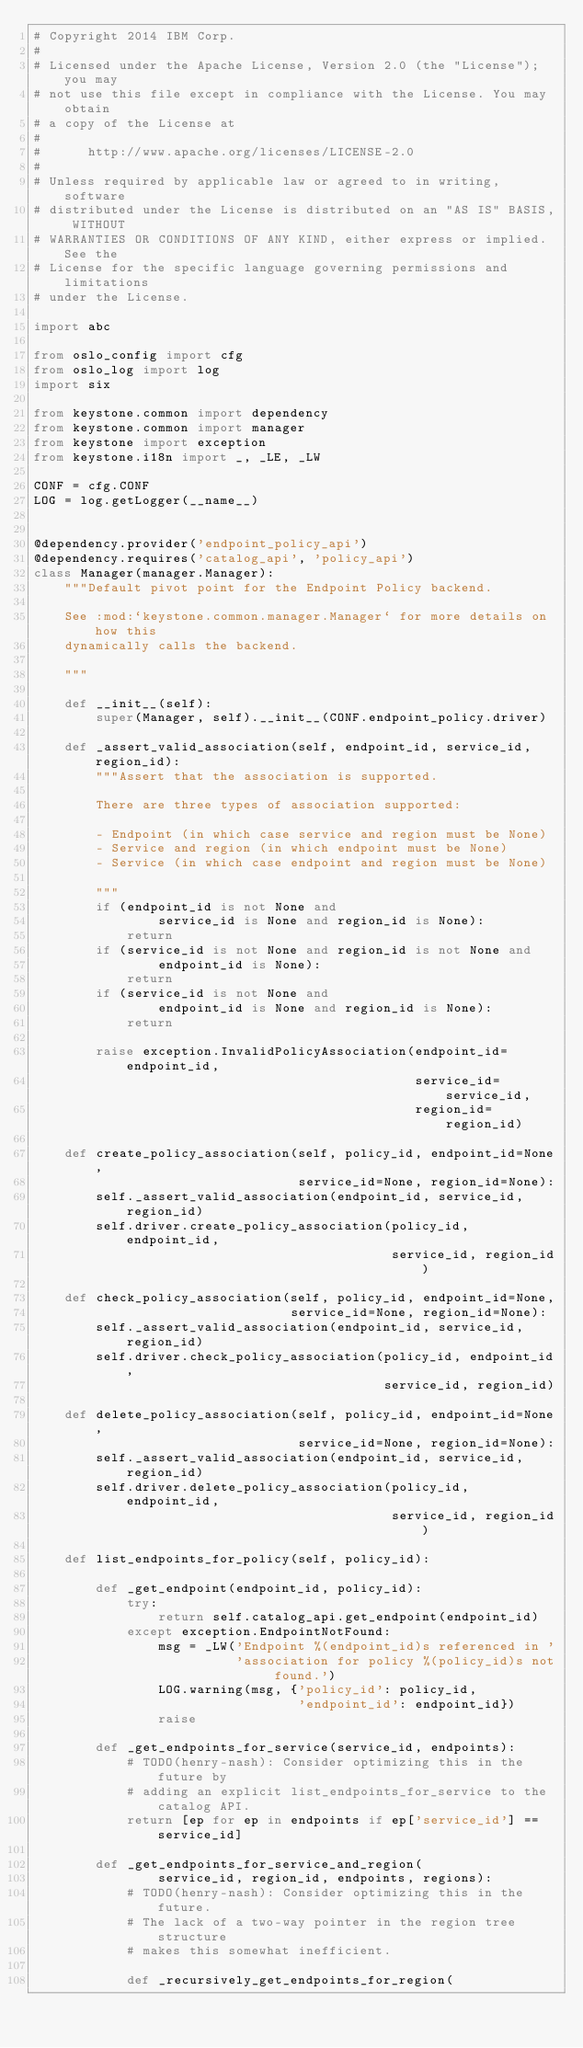<code> <loc_0><loc_0><loc_500><loc_500><_Python_># Copyright 2014 IBM Corp.
#
# Licensed under the Apache License, Version 2.0 (the "License"); you may
# not use this file except in compliance with the License. You may obtain
# a copy of the License at
#
#      http://www.apache.org/licenses/LICENSE-2.0
#
# Unless required by applicable law or agreed to in writing, software
# distributed under the License is distributed on an "AS IS" BASIS, WITHOUT
# WARRANTIES OR CONDITIONS OF ANY KIND, either express or implied. See the
# License for the specific language governing permissions and limitations
# under the License.

import abc

from oslo_config import cfg
from oslo_log import log
import six

from keystone.common import dependency
from keystone.common import manager
from keystone import exception
from keystone.i18n import _, _LE, _LW

CONF = cfg.CONF
LOG = log.getLogger(__name__)


@dependency.provider('endpoint_policy_api')
@dependency.requires('catalog_api', 'policy_api')
class Manager(manager.Manager):
    """Default pivot point for the Endpoint Policy backend.

    See :mod:`keystone.common.manager.Manager` for more details on how this
    dynamically calls the backend.

    """

    def __init__(self):
        super(Manager, self).__init__(CONF.endpoint_policy.driver)

    def _assert_valid_association(self, endpoint_id, service_id, region_id):
        """Assert that the association is supported.

        There are three types of association supported:

        - Endpoint (in which case service and region must be None)
        - Service and region (in which endpoint must be None)
        - Service (in which case endpoint and region must be None)

        """
        if (endpoint_id is not None and
                service_id is None and region_id is None):
            return
        if (service_id is not None and region_id is not None and
                endpoint_id is None):
            return
        if (service_id is not None and
                endpoint_id is None and region_id is None):
            return

        raise exception.InvalidPolicyAssociation(endpoint_id=endpoint_id,
                                                 service_id=service_id,
                                                 region_id=region_id)

    def create_policy_association(self, policy_id, endpoint_id=None,
                                  service_id=None, region_id=None):
        self._assert_valid_association(endpoint_id, service_id, region_id)
        self.driver.create_policy_association(policy_id, endpoint_id,
                                              service_id, region_id)

    def check_policy_association(self, policy_id, endpoint_id=None,
                                 service_id=None, region_id=None):
        self._assert_valid_association(endpoint_id, service_id, region_id)
        self.driver.check_policy_association(policy_id, endpoint_id,
                                             service_id, region_id)

    def delete_policy_association(self, policy_id, endpoint_id=None,
                                  service_id=None, region_id=None):
        self._assert_valid_association(endpoint_id, service_id, region_id)
        self.driver.delete_policy_association(policy_id, endpoint_id,
                                              service_id, region_id)

    def list_endpoints_for_policy(self, policy_id):

        def _get_endpoint(endpoint_id, policy_id):
            try:
                return self.catalog_api.get_endpoint(endpoint_id)
            except exception.EndpointNotFound:
                msg = _LW('Endpoint %(endpoint_id)s referenced in '
                          'association for policy %(policy_id)s not found.')
                LOG.warning(msg, {'policy_id': policy_id,
                                  'endpoint_id': endpoint_id})
                raise

        def _get_endpoints_for_service(service_id, endpoints):
            # TODO(henry-nash): Consider optimizing this in the future by
            # adding an explicit list_endpoints_for_service to the catalog API.
            return [ep for ep in endpoints if ep['service_id'] == service_id]

        def _get_endpoints_for_service_and_region(
                service_id, region_id, endpoints, regions):
            # TODO(henry-nash): Consider optimizing this in the future.
            # The lack of a two-way pointer in the region tree structure
            # makes this somewhat inefficient.

            def _recursively_get_endpoints_for_region(</code> 